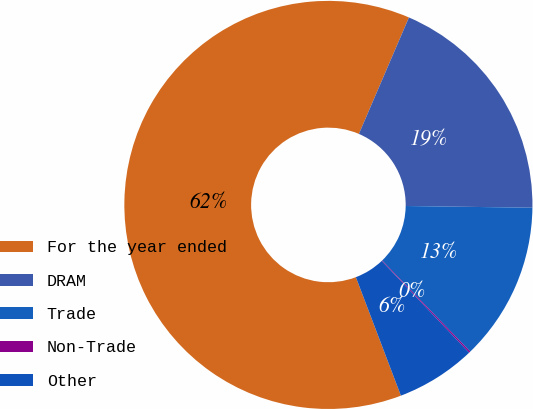<chart> <loc_0><loc_0><loc_500><loc_500><pie_chart><fcel>For the year ended<fcel>DRAM<fcel>Trade<fcel>Non-Trade<fcel>Other<nl><fcel>62.24%<fcel>18.76%<fcel>12.55%<fcel>0.12%<fcel>6.33%<nl></chart> 